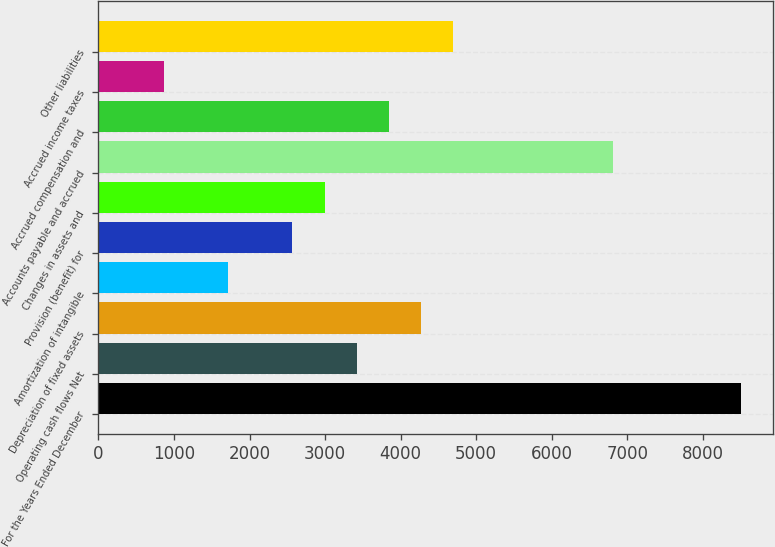Convert chart to OTSL. <chart><loc_0><loc_0><loc_500><loc_500><bar_chart><fcel>For the Years Ended December<fcel>Operating cash flows Net<fcel>Depreciation of fixed assets<fcel>Amortization of intangible<fcel>Provision (benefit) for<fcel>Changes in assets and<fcel>Accounts payable and accrued<fcel>Accrued compensation and<fcel>Accrued income taxes<fcel>Other liabilities<nl><fcel>8507<fcel>3416.6<fcel>4265<fcel>1719.8<fcel>2568.2<fcel>2992.4<fcel>6810.2<fcel>3840.8<fcel>871.4<fcel>4689.2<nl></chart> 